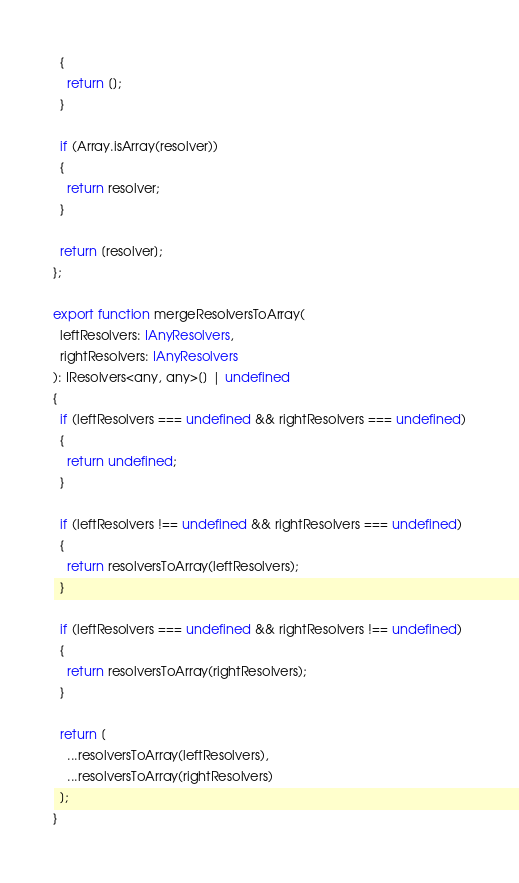Convert code to text. <code><loc_0><loc_0><loc_500><loc_500><_TypeScript_>  {
    return [];
  }

  if (Array.isArray(resolver))
  {
    return resolver;
  }

  return [resolver];
};

export function mergeResolversToArray(
  leftResolvers: IAnyResolvers,
  rightResolvers: IAnyResolvers
): IResolvers<any, any>[] | undefined
{
  if (leftResolvers === undefined && rightResolvers === undefined)
  {
    return undefined;
  }

  if (leftResolvers !== undefined && rightResolvers === undefined)
  {
    return resolversToArray(leftResolvers);
  }

  if (leftResolvers === undefined && rightResolvers !== undefined)
  {
    return resolversToArray(rightResolvers);
  }

  return [
    ...resolversToArray(leftResolvers),
    ...resolversToArray(rightResolvers)
  ];
}
</code> 